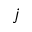<formula> <loc_0><loc_0><loc_500><loc_500>j</formula> 